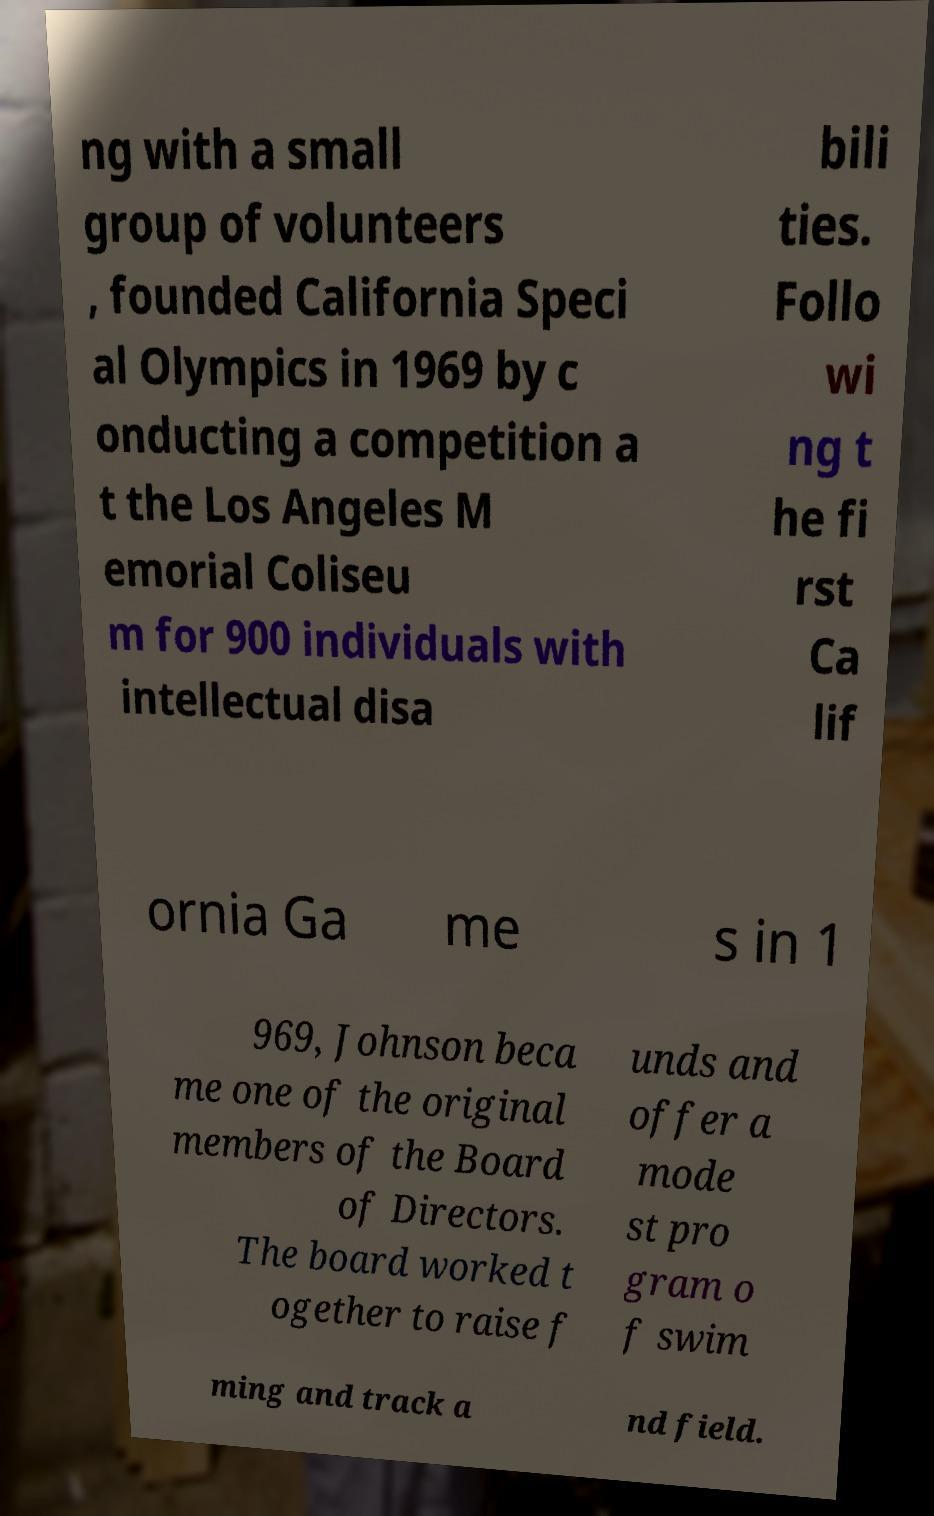For documentation purposes, I need the text within this image transcribed. Could you provide that? ng with a small group of volunteers , founded California Speci al Olympics in 1969 by c onducting a competition a t the Los Angeles M emorial Coliseu m for 900 individuals with intellectual disa bili ties. Follo wi ng t he fi rst Ca lif ornia Ga me s in 1 969, Johnson beca me one of the original members of the Board of Directors. The board worked t ogether to raise f unds and offer a mode st pro gram o f swim ming and track a nd field. 